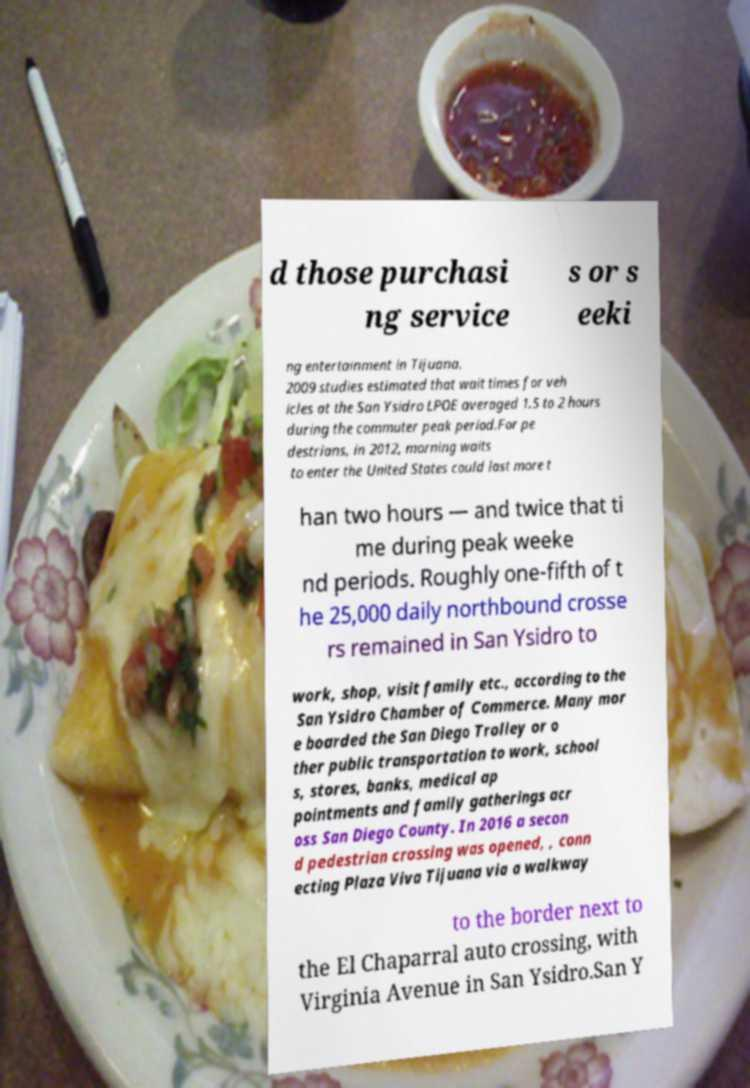Could you extract and type out the text from this image? d those purchasi ng service s or s eeki ng entertainment in Tijuana. 2009 studies estimated that wait times for veh icles at the San Ysidro LPOE averaged 1.5 to 2 hours during the commuter peak period.For pe destrians, in 2012, morning waits to enter the United States could last more t han two hours — and twice that ti me during peak weeke nd periods. Roughly one-fifth of t he 25,000 daily northbound crosse rs remained in San Ysidro to work, shop, visit family etc., according to the San Ysidro Chamber of Commerce. Many mor e boarded the San Diego Trolley or o ther public transportation to work, school s, stores, banks, medical ap pointments and family gatherings acr oss San Diego County. In 2016 a secon d pedestrian crossing was opened, , conn ecting Plaza Viva Tijuana via a walkway to the border next to the El Chaparral auto crossing, with Virginia Avenue in San Ysidro.San Y 